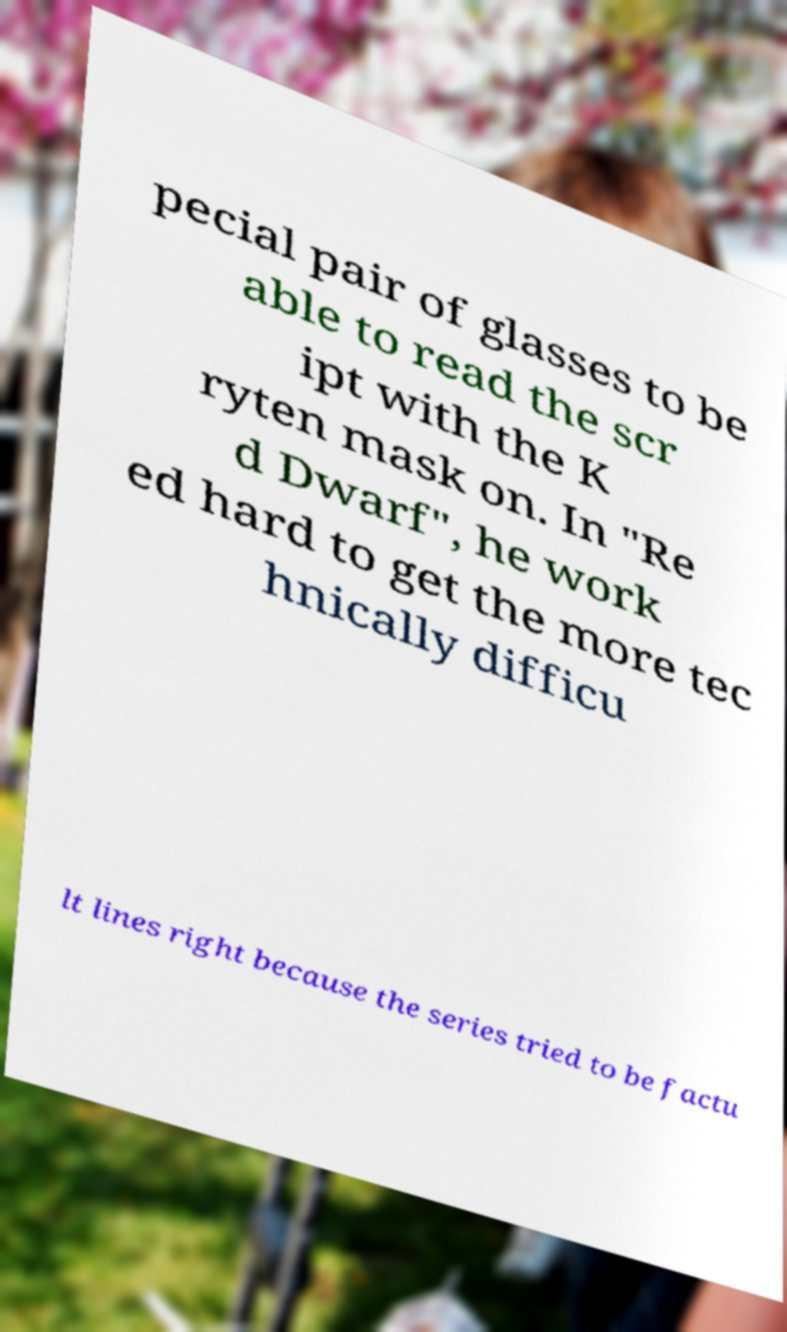What messages or text are displayed in this image? I need them in a readable, typed format. pecial pair of glasses to be able to read the scr ipt with the K ryten mask on. In "Re d Dwarf", he work ed hard to get the more tec hnically difficu lt lines right because the series tried to be factu 